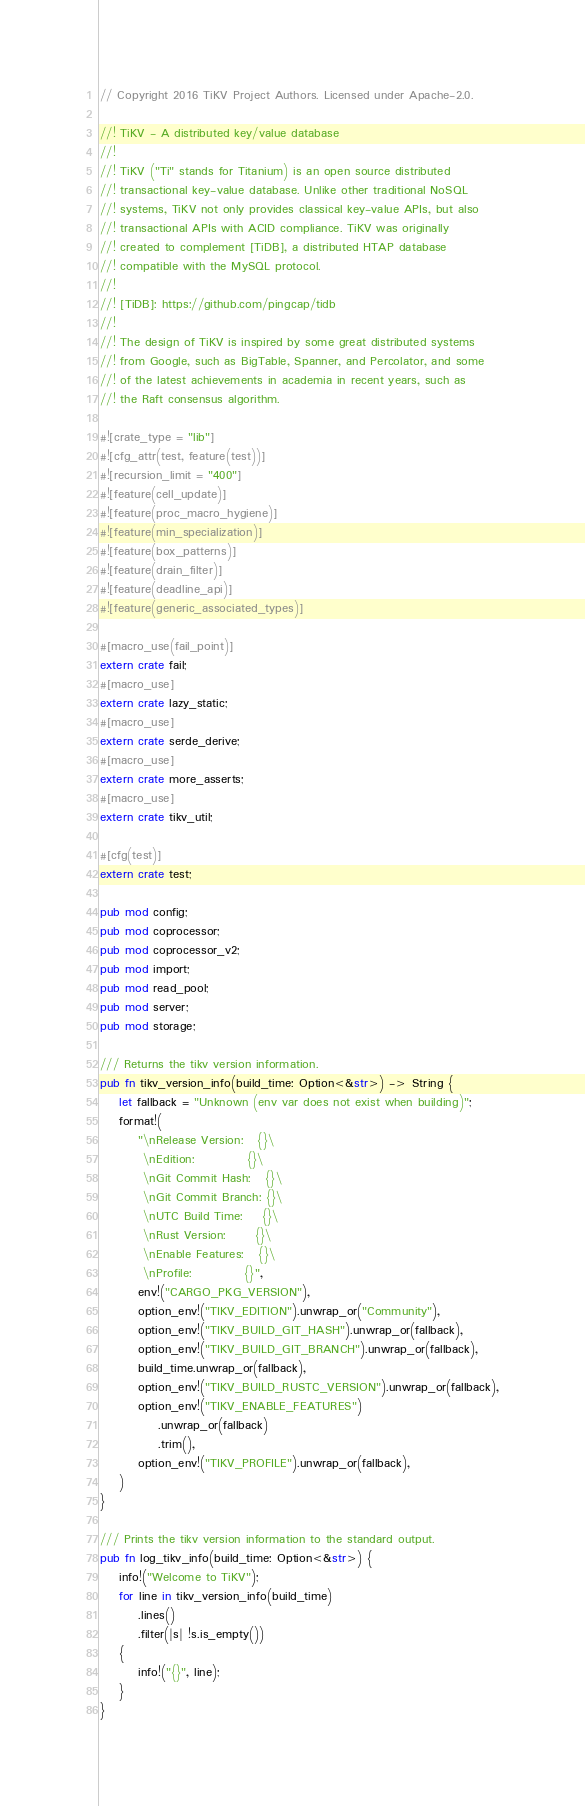<code> <loc_0><loc_0><loc_500><loc_500><_Rust_>// Copyright 2016 TiKV Project Authors. Licensed under Apache-2.0.

//! TiKV - A distributed key/value database
//!
//! TiKV ("Ti" stands for Titanium) is an open source distributed
//! transactional key-value database. Unlike other traditional NoSQL
//! systems, TiKV not only provides classical key-value APIs, but also
//! transactional APIs with ACID compliance. TiKV was originally
//! created to complement [TiDB], a distributed HTAP database
//! compatible with the MySQL protocol.
//!
//! [TiDB]: https://github.com/pingcap/tidb
//!
//! The design of TiKV is inspired by some great distributed systems
//! from Google, such as BigTable, Spanner, and Percolator, and some
//! of the latest achievements in academia in recent years, such as
//! the Raft consensus algorithm.

#![crate_type = "lib"]
#![cfg_attr(test, feature(test))]
#![recursion_limit = "400"]
#![feature(cell_update)]
#![feature(proc_macro_hygiene)]
#![feature(min_specialization)]
#![feature(box_patterns)]
#![feature(drain_filter)]
#![feature(deadline_api)]
#![feature(generic_associated_types)]

#[macro_use(fail_point)]
extern crate fail;
#[macro_use]
extern crate lazy_static;
#[macro_use]
extern crate serde_derive;
#[macro_use]
extern crate more_asserts;
#[macro_use]
extern crate tikv_util;

#[cfg(test)]
extern crate test;

pub mod config;
pub mod coprocessor;
pub mod coprocessor_v2;
pub mod import;
pub mod read_pool;
pub mod server;
pub mod storage;

/// Returns the tikv version information.
pub fn tikv_version_info(build_time: Option<&str>) -> String {
    let fallback = "Unknown (env var does not exist when building)";
    format!(
        "\nRelease Version:   {}\
         \nEdition:           {}\
         \nGit Commit Hash:   {}\
         \nGit Commit Branch: {}\
         \nUTC Build Time:    {}\
         \nRust Version:      {}\
         \nEnable Features:   {}\
         \nProfile:           {}",
        env!("CARGO_PKG_VERSION"),
        option_env!("TIKV_EDITION").unwrap_or("Community"),
        option_env!("TIKV_BUILD_GIT_HASH").unwrap_or(fallback),
        option_env!("TIKV_BUILD_GIT_BRANCH").unwrap_or(fallback),
        build_time.unwrap_or(fallback),
        option_env!("TIKV_BUILD_RUSTC_VERSION").unwrap_or(fallback),
        option_env!("TIKV_ENABLE_FEATURES")
            .unwrap_or(fallback)
            .trim(),
        option_env!("TIKV_PROFILE").unwrap_or(fallback),
    )
}

/// Prints the tikv version information to the standard output.
pub fn log_tikv_info(build_time: Option<&str>) {
    info!("Welcome to TiKV");
    for line in tikv_version_info(build_time)
        .lines()
        .filter(|s| !s.is_empty())
    {
        info!("{}", line);
    }
}
</code> 